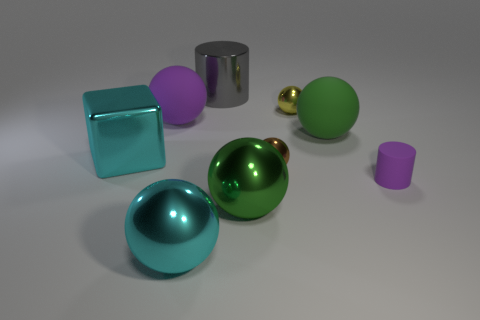The object that is both right of the yellow shiny thing and behind the metallic block is made of what material?
Provide a succinct answer. Rubber. How many shiny spheres are behind the big cube that is behind the large cyan ball?
Keep it short and to the point. 1. There is a brown object; what shape is it?
Your response must be concise. Sphere. What shape is the large thing that is made of the same material as the purple sphere?
Make the answer very short. Sphere. Does the tiny yellow thing that is right of the big gray metal object have the same shape as the large green metallic thing?
Offer a very short reply. Yes. What shape is the small metal thing that is behind the green rubber thing?
Make the answer very short. Sphere. There is a big matte thing that is the same color as the tiny matte cylinder; what is its shape?
Offer a terse response. Sphere. How many shiny objects are the same size as the cyan metal sphere?
Offer a terse response. 3. What is the color of the big metallic cylinder?
Your answer should be compact. Gray. Do the shiny block and the metallic sphere that is left of the big gray shiny thing have the same color?
Keep it short and to the point. Yes. 